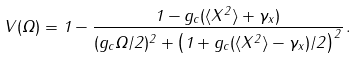Convert formula to latex. <formula><loc_0><loc_0><loc_500><loc_500>V ( \Omega ) = 1 - \frac { 1 - { g _ { c } } ( \langle X ^ { 2 } \rangle + \gamma _ { x } ) } { ( { g _ { c } } \Omega / 2 ) ^ { 2 } + \left ( 1 + { g _ { c } } ( \langle X ^ { 2 } \rangle - \gamma _ { x } ) / 2 \right ) ^ { 2 } } \, .</formula> 